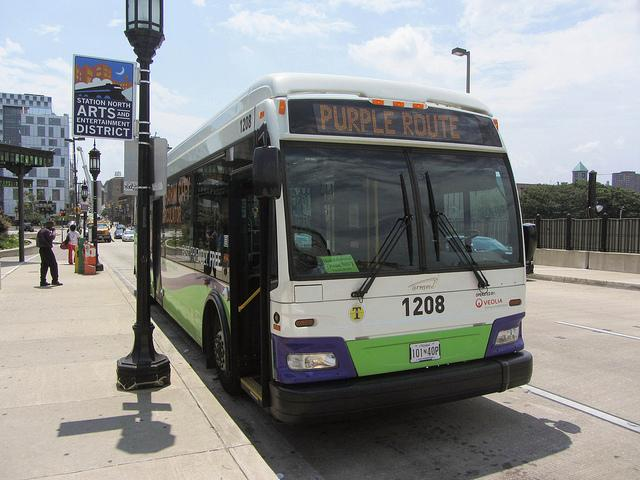What is the bus doing near the sidewalk? Please explain your reasoning. stopping. The bus has stopped near the sidewalk. 